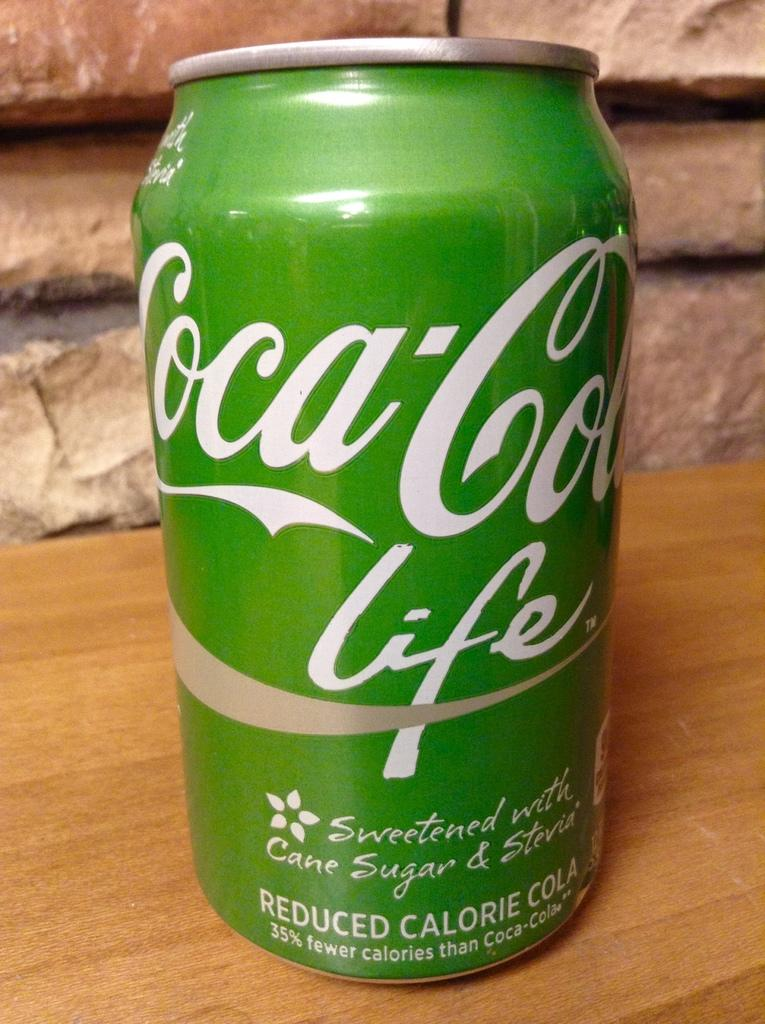<image>
Present a compact description of the photo's key features. A green can of Coca-Cola Life written on it. 